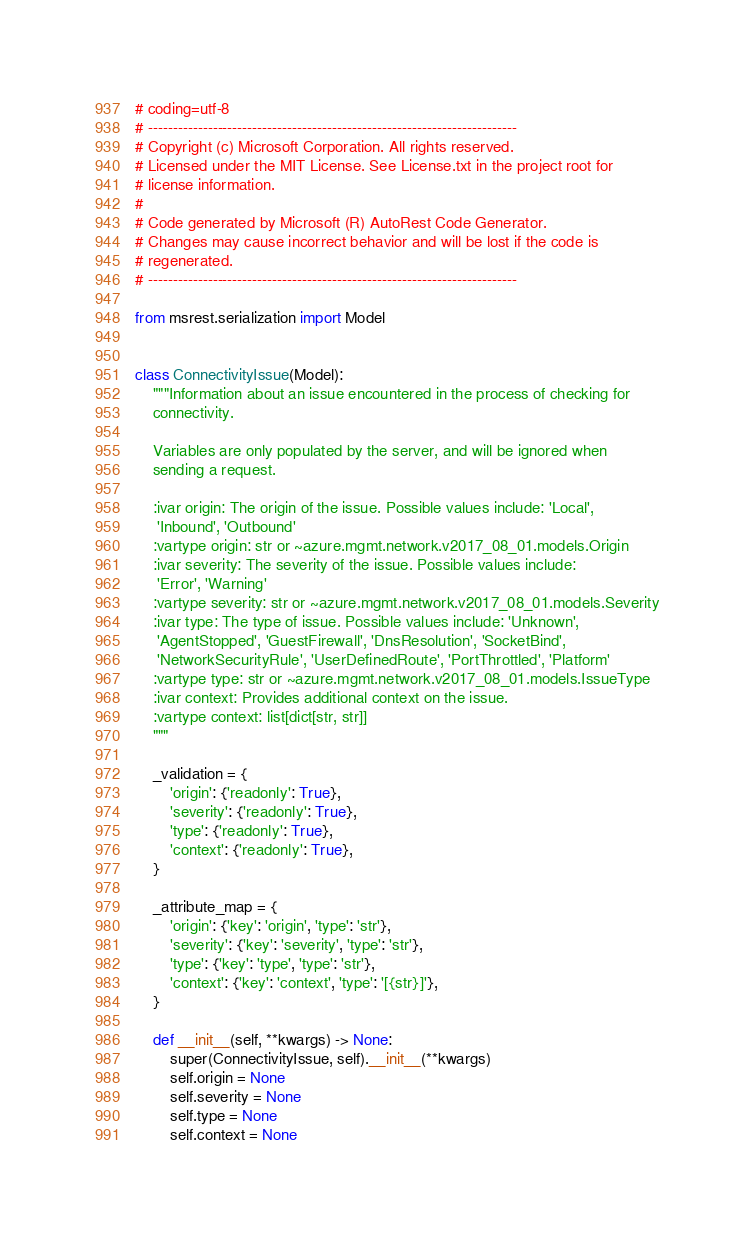<code> <loc_0><loc_0><loc_500><loc_500><_Python_># coding=utf-8
# --------------------------------------------------------------------------
# Copyright (c) Microsoft Corporation. All rights reserved.
# Licensed under the MIT License. See License.txt in the project root for
# license information.
#
# Code generated by Microsoft (R) AutoRest Code Generator.
# Changes may cause incorrect behavior and will be lost if the code is
# regenerated.
# --------------------------------------------------------------------------

from msrest.serialization import Model


class ConnectivityIssue(Model):
    """Information about an issue encountered in the process of checking for
    connectivity.

    Variables are only populated by the server, and will be ignored when
    sending a request.

    :ivar origin: The origin of the issue. Possible values include: 'Local',
     'Inbound', 'Outbound'
    :vartype origin: str or ~azure.mgmt.network.v2017_08_01.models.Origin
    :ivar severity: The severity of the issue. Possible values include:
     'Error', 'Warning'
    :vartype severity: str or ~azure.mgmt.network.v2017_08_01.models.Severity
    :ivar type: The type of issue. Possible values include: 'Unknown',
     'AgentStopped', 'GuestFirewall', 'DnsResolution', 'SocketBind',
     'NetworkSecurityRule', 'UserDefinedRoute', 'PortThrottled', 'Platform'
    :vartype type: str or ~azure.mgmt.network.v2017_08_01.models.IssueType
    :ivar context: Provides additional context on the issue.
    :vartype context: list[dict[str, str]]
    """

    _validation = {
        'origin': {'readonly': True},
        'severity': {'readonly': True},
        'type': {'readonly': True},
        'context': {'readonly': True},
    }

    _attribute_map = {
        'origin': {'key': 'origin', 'type': 'str'},
        'severity': {'key': 'severity', 'type': 'str'},
        'type': {'key': 'type', 'type': 'str'},
        'context': {'key': 'context', 'type': '[{str}]'},
    }

    def __init__(self, **kwargs) -> None:
        super(ConnectivityIssue, self).__init__(**kwargs)
        self.origin = None
        self.severity = None
        self.type = None
        self.context = None
</code> 